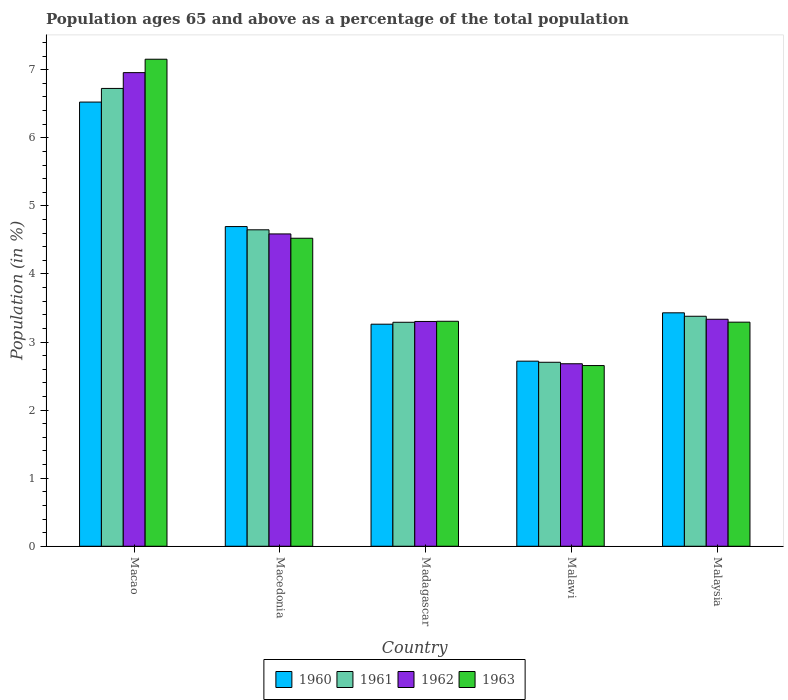How many different coloured bars are there?
Your answer should be very brief. 4. How many groups of bars are there?
Offer a terse response. 5. Are the number of bars per tick equal to the number of legend labels?
Your answer should be very brief. Yes. Are the number of bars on each tick of the X-axis equal?
Your response must be concise. Yes. How many bars are there on the 2nd tick from the left?
Your answer should be compact. 4. How many bars are there on the 3rd tick from the right?
Provide a short and direct response. 4. What is the label of the 3rd group of bars from the left?
Give a very brief answer. Madagascar. What is the percentage of the population ages 65 and above in 1963 in Macedonia?
Your answer should be very brief. 4.52. Across all countries, what is the maximum percentage of the population ages 65 and above in 1961?
Give a very brief answer. 6.73. Across all countries, what is the minimum percentage of the population ages 65 and above in 1961?
Your answer should be very brief. 2.7. In which country was the percentage of the population ages 65 and above in 1963 maximum?
Make the answer very short. Macao. In which country was the percentage of the population ages 65 and above in 1961 minimum?
Give a very brief answer. Malawi. What is the total percentage of the population ages 65 and above in 1963 in the graph?
Give a very brief answer. 20.93. What is the difference between the percentage of the population ages 65 and above in 1963 in Macedonia and that in Madagascar?
Offer a terse response. 1.22. What is the difference between the percentage of the population ages 65 and above in 1961 in Madagascar and the percentage of the population ages 65 and above in 1960 in Malawi?
Offer a very short reply. 0.57. What is the average percentage of the population ages 65 and above in 1961 per country?
Provide a succinct answer. 4.15. What is the difference between the percentage of the population ages 65 and above of/in 1963 and percentage of the population ages 65 and above of/in 1960 in Malawi?
Offer a terse response. -0.06. In how many countries, is the percentage of the population ages 65 and above in 1962 greater than 3.6?
Offer a terse response. 2. What is the ratio of the percentage of the population ages 65 and above in 1962 in Malawi to that in Malaysia?
Your response must be concise. 0.8. What is the difference between the highest and the second highest percentage of the population ages 65 and above in 1962?
Make the answer very short. -1.25. What is the difference between the highest and the lowest percentage of the population ages 65 and above in 1962?
Your answer should be compact. 4.28. In how many countries, is the percentage of the population ages 65 and above in 1962 greater than the average percentage of the population ages 65 and above in 1962 taken over all countries?
Keep it short and to the point. 2. What does the 2nd bar from the left in Malawi represents?
Give a very brief answer. 1961. Is it the case that in every country, the sum of the percentage of the population ages 65 and above in 1960 and percentage of the population ages 65 and above in 1963 is greater than the percentage of the population ages 65 and above in 1962?
Your answer should be compact. Yes. What is the difference between two consecutive major ticks on the Y-axis?
Your answer should be very brief. 1. Are the values on the major ticks of Y-axis written in scientific E-notation?
Your answer should be compact. No. Where does the legend appear in the graph?
Provide a succinct answer. Bottom center. How many legend labels are there?
Provide a succinct answer. 4. How are the legend labels stacked?
Provide a short and direct response. Horizontal. What is the title of the graph?
Keep it short and to the point. Population ages 65 and above as a percentage of the total population. What is the label or title of the X-axis?
Ensure brevity in your answer.  Country. What is the label or title of the Y-axis?
Provide a short and direct response. Population (in %). What is the Population (in %) in 1960 in Macao?
Offer a terse response. 6.53. What is the Population (in %) in 1961 in Macao?
Keep it short and to the point. 6.73. What is the Population (in %) in 1962 in Macao?
Your response must be concise. 6.96. What is the Population (in %) in 1963 in Macao?
Make the answer very short. 7.15. What is the Population (in %) in 1960 in Macedonia?
Provide a short and direct response. 4.7. What is the Population (in %) in 1961 in Macedonia?
Your answer should be compact. 4.65. What is the Population (in %) of 1962 in Macedonia?
Keep it short and to the point. 4.59. What is the Population (in %) in 1963 in Macedonia?
Offer a very short reply. 4.52. What is the Population (in %) of 1960 in Madagascar?
Make the answer very short. 3.26. What is the Population (in %) in 1961 in Madagascar?
Your response must be concise. 3.29. What is the Population (in %) of 1962 in Madagascar?
Offer a terse response. 3.3. What is the Population (in %) in 1963 in Madagascar?
Make the answer very short. 3.31. What is the Population (in %) of 1960 in Malawi?
Keep it short and to the point. 2.72. What is the Population (in %) in 1961 in Malawi?
Keep it short and to the point. 2.7. What is the Population (in %) of 1962 in Malawi?
Keep it short and to the point. 2.68. What is the Population (in %) of 1963 in Malawi?
Make the answer very short. 2.65. What is the Population (in %) of 1960 in Malaysia?
Offer a terse response. 3.43. What is the Population (in %) in 1961 in Malaysia?
Your answer should be compact. 3.38. What is the Population (in %) in 1962 in Malaysia?
Make the answer very short. 3.33. What is the Population (in %) in 1963 in Malaysia?
Keep it short and to the point. 3.29. Across all countries, what is the maximum Population (in %) in 1960?
Provide a succinct answer. 6.53. Across all countries, what is the maximum Population (in %) of 1961?
Make the answer very short. 6.73. Across all countries, what is the maximum Population (in %) of 1962?
Your answer should be compact. 6.96. Across all countries, what is the maximum Population (in %) of 1963?
Offer a terse response. 7.15. Across all countries, what is the minimum Population (in %) of 1960?
Your answer should be compact. 2.72. Across all countries, what is the minimum Population (in %) in 1961?
Give a very brief answer. 2.7. Across all countries, what is the minimum Population (in %) of 1962?
Offer a very short reply. 2.68. Across all countries, what is the minimum Population (in %) in 1963?
Provide a succinct answer. 2.65. What is the total Population (in %) of 1960 in the graph?
Your response must be concise. 20.63. What is the total Population (in %) of 1961 in the graph?
Ensure brevity in your answer.  20.75. What is the total Population (in %) in 1962 in the graph?
Your answer should be compact. 20.86. What is the total Population (in %) in 1963 in the graph?
Offer a very short reply. 20.93. What is the difference between the Population (in %) in 1960 in Macao and that in Macedonia?
Keep it short and to the point. 1.83. What is the difference between the Population (in %) of 1961 in Macao and that in Macedonia?
Offer a terse response. 2.08. What is the difference between the Population (in %) in 1962 in Macao and that in Macedonia?
Your answer should be very brief. 2.37. What is the difference between the Population (in %) in 1963 in Macao and that in Macedonia?
Offer a terse response. 2.63. What is the difference between the Population (in %) in 1960 in Macao and that in Madagascar?
Provide a succinct answer. 3.26. What is the difference between the Population (in %) of 1961 in Macao and that in Madagascar?
Provide a succinct answer. 3.44. What is the difference between the Population (in %) of 1962 in Macao and that in Madagascar?
Your response must be concise. 3.66. What is the difference between the Population (in %) of 1963 in Macao and that in Madagascar?
Ensure brevity in your answer.  3.85. What is the difference between the Population (in %) in 1960 in Macao and that in Malawi?
Your answer should be very brief. 3.81. What is the difference between the Population (in %) in 1961 in Macao and that in Malawi?
Ensure brevity in your answer.  4.02. What is the difference between the Population (in %) of 1962 in Macao and that in Malawi?
Your response must be concise. 4.28. What is the difference between the Population (in %) in 1963 in Macao and that in Malawi?
Your response must be concise. 4.5. What is the difference between the Population (in %) of 1960 in Macao and that in Malaysia?
Give a very brief answer. 3.1. What is the difference between the Population (in %) of 1961 in Macao and that in Malaysia?
Keep it short and to the point. 3.35. What is the difference between the Population (in %) of 1962 in Macao and that in Malaysia?
Give a very brief answer. 3.62. What is the difference between the Population (in %) of 1963 in Macao and that in Malaysia?
Your answer should be very brief. 3.86. What is the difference between the Population (in %) in 1960 in Macedonia and that in Madagascar?
Make the answer very short. 1.43. What is the difference between the Population (in %) of 1961 in Macedonia and that in Madagascar?
Offer a very short reply. 1.36. What is the difference between the Population (in %) in 1962 in Macedonia and that in Madagascar?
Make the answer very short. 1.29. What is the difference between the Population (in %) of 1963 in Macedonia and that in Madagascar?
Provide a succinct answer. 1.22. What is the difference between the Population (in %) in 1960 in Macedonia and that in Malawi?
Provide a succinct answer. 1.98. What is the difference between the Population (in %) of 1961 in Macedonia and that in Malawi?
Offer a terse response. 1.95. What is the difference between the Population (in %) of 1962 in Macedonia and that in Malawi?
Provide a short and direct response. 1.91. What is the difference between the Population (in %) in 1963 in Macedonia and that in Malawi?
Keep it short and to the point. 1.87. What is the difference between the Population (in %) of 1960 in Macedonia and that in Malaysia?
Provide a succinct answer. 1.27. What is the difference between the Population (in %) in 1961 in Macedonia and that in Malaysia?
Your response must be concise. 1.27. What is the difference between the Population (in %) in 1962 in Macedonia and that in Malaysia?
Keep it short and to the point. 1.25. What is the difference between the Population (in %) in 1963 in Macedonia and that in Malaysia?
Your answer should be very brief. 1.23. What is the difference between the Population (in %) of 1960 in Madagascar and that in Malawi?
Your response must be concise. 0.54. What is the difference between the Population (in %) in 1961 in Madagascar and that in Malawi?
Offer a terse response. 0.59. What is the difference between the Population (in %) in 1962 in Madagascar and that in Malawi?
Ensure brevity in your answer.  0.62. What is the difference between the Population (in %) in 1963 in Madagascar and that in Malawi?
Provide a succinct answer. 0.65. What is the difference between the Population (in %) of 1960 in Madagascar and that in Malaysia?
Keep it short and to the point. -0.17. What is the difference between the Population (in %) of 1961 in Madagascar and that in Malaysia?
Offer a very short reply. -0.09. What is the difference between the Population (in %) in 1962 in Madagascar and that in Malaysia?
Offer a terse response. -0.03. What is the difference between the Population (in %) of 1963 in Madagascar and that in Malaysia?
Your answer should be compact. 0.01. What is the difference between the Population (in %) of 1960 in Malawi and that in Malaysia?
Give a very brief answer. -0.71. What is the difference between the Population (in %) in 1961 in Malawi and that in Malaysia?
Keep it short and to the point. -0.68. What is the difference between the Population (in %) of 1962 in Malawi and that in Malaysia?
Offer a very short reply. -0.65. What is the difference between the Population (in %) in 1963 in Malawi and that in Malaysia?
Ensure brevity in your answer.  -0.64. What is the difference between the Population (in %) of 1960 in Macao and the Population (in %) of 1961 in Macedonia?
Provide a short and direct response. 1.88. What is the difference between the Population (in %) of 1960 in Macao and the Population (in %) of 1962 in Macedonia?
Offer a very short reply. 1.94. What is the difference between the Population (in %) of 1960 in Macao and the Population (in %) of 1963 in Macedonia?
Your answer should be very brief. 2. What is the difference between the Population (in %) of 1961 in Macao and the Population (in %) of 1962 in Macedonia?
Ensure brevity in your answer.  2.14. What is the difference between the Population (in %) in 1961 in Macao and the Population (in %) in 1963 in Macedonia?
Your response must be concise. 2.2. What is the difference between the Population (in %) in 1962 in Macao and the Population (in %) in 1963 in Macedonia?
Provide a short and direct response. 2.43. What is the difference between the Population (in %) of 1960 in Macao and the Population (in %) of 1961 in Madagascar?
Keep it short and to the point. 3.23. What is the difference between the Population (in %) of 1960 in Macao and the Population (in %) of 1962 in Madagascar?
Keep it short and to the point. 3.22. What is the difference between the Population (in %) in 1960 in Macao and the Population (in %) in 1963 in Madagascar?
Your answer should be very brief. 3.22. What is the difference between the Population (in %) of 1961 in Macao and the Population (in %) of 1962 in Madagascar?
Give a very brief answer. 3.42. What is the difference between the Population (in %) in 1961 in Macao and the Population (in %) in 1963 in Madagascar?
Give a very brief answer. 3.42. What is the difference between the Population (in %) of 1962 in Macao and the Population (in %) of 1963 in Madagascar?
Ensure brevity in your answer.  3.65. What is the difference between the Population (in %) of 1960 in Macao and the Population (in %) of 1961 in Malawi?
Provide a short and direct response. 3.82. What is the difference between the Population (in %) of 1960 in Macao and the Population (in %) of 1962 in Malawi?
Give a very brief answer. 3.84. What is the difference between the Population (in %) of 1960 in Macao and the Population (in %) of 1963 in Malawi?
Make the answer very short. 3.87. What is the difference between the Population (in %) of 1961 in Macao and the Population (in %) of 1962 in Malawi?
Ensure brevity in your answer.  4.04. What is the difference between the Population (in %) of 1961 in Macao and the Population (in %) of 1963 in Malawi?
Give a very brief answer. 4.07. What is the difference between the Population (in %) of 1962 in Macao and the Population (in %) of 1963 in Malawi?
Ensure brevity in your answer.  4.3. What is the difference between the Population (in %) in 1960 in Macao and the Population (in %) in 1961 in Malaysia?
Provide a short and direct response. 3.15. What is the difference between the Population (in %) in 1960 in Macao and the Population (in %) in 1962 in Malaysia?
Provide a succinct answer. 3.19. What is the difference between the Population (in %) in 1960 in Macao and the Population (in %) in 1963 in Malaysia?
Offer a terse response. 3.23. What is the difference between the Population (in %) in 1961 in Macao and the Population (in %) in 1962 in Malaysia?
Your response must be concise. 3.39. What is the difference between the Population (in %) in 1961 in Macao and the Population (in %) in 1963 in Malaysia?
Offer a very short reply. 3.43. What is the difference between the Population (in %) in 1962 in Macao and the Population (in %) in 1963 in Malaysia?
Your answer should be compact. 3.67. What is the difference between the Population (in %) in 1960 in Macedonia and the Population (in %) in 1961 in Madagascar?
Your answer should be compact. 1.41. What is the difference between the Population (in %) in 1960 in Macedonia and the Population (in %) in 1962 in Madagascar?
Provide a short and direct response. 1.39. What is the difference between the Population (in %) of 1960 in Macedonia and the Population (in %) of 1963 in Madagascar?
Provide a short and direct response. 1.39. What is the difference between the Population (in %) of 1961 in Macedonia and the Population (in %) of 1962 in Madagascar?
Your answer should be compact. 1.35. What is the difference between the Population (in %) of 1961 in Macedonia and the Population (in %) of 1963 in Madagascar?
Give a very brief answer. 1.34. What is the difference between the Population (in %) of 1962 in Macedonia and the Population (in %) of 1963 in Madagascar?
Offer a terse response. 1.28. What is the difference between the Population (in %) in 1960 in Macedonia and the Population (in %) in 1961 in Malawi?
Offer a very short reply. 1.99. What is the difference between the Population (in %) of 1960 in Macedonia and the Population (in %) of 1962 in Malawi?
Ensure brevity in your answer.  2.02. What is the difference between the Population (in %) of 1960 in Macedonia and the Population (in %) of 1963 in Malawi?
Provide a short and direct response. 2.04. What is the difference between the Population (in %) of 1961 in Macedonia and the Population (in %) of 1962 in Malawi?
Provide a succinct answer. 1.97. What is the difference between the Population (in %) of 1961 in Macedonia and the Population (in %) of 1963 in Malawi?
Offer a very short reply. 1.99. What is the difference between the Population (in %) of 1962 in Macedonia and the Population (in %) of 1963 in Malawi?
Keep it short and to the point. 1.93. What is the difference between the Population (in %) in 1960 in Macedonia and the Population (in %) in 1961 in Malaysia?
Make the answer very short. 1.32. What is the difference between the Population (in %) in 1960 in Macedonia and the Population (in %) in 1962 in Malaysia?
Offer a terse response. 1.36. What is the difference between the Population (in %) in 1960 in Macedonia and the Population (in %) in 1963 in Malaysia?
Offer a terse response. 1.4. What is the difference between the Population (in %) in 1961 in Macedonia and the Population (in %) in 1962 in Malaysia?
Your answer should be compact. 1.31. What is the difference between the Population (in %) in 1961 in Macedonia and the Population (in %) in 1963 in Malaysia?
Your response must be concise. 1.36. What is the difference between the Population (in %) of 1962 in Macedonia and the Population (in %) of 1963 in Malaysia?
Provide a short and direct response. 1.3. What is the difference between the Population (in %) of 1960 in Madagascar and the Population (in %) of 1961 in Malawi?
Ensure brevity in your answer.  0.56. What is the difference between the Population (in %) of 1960 in Madagascar and the Population (in %) of 1962 in Malawi?
Provide a succinct answer. 0.58. What is the difference between the Population (in %) in 1960 in Madagascar and the Population (in %) in 1963 in Malawi?
Offer a very short reply. 0.61. What is the difference between the Population (in %) in 1961 in Madagascar and the Population (in %) in 1962 in Malawi?
Make the answer very short. 0.61. What is the difference between the Population (in %) of 1961 in Madagascar and the Population (in %) of 1963 in Malawi?
Give a very brief answer. 0.64. What is the difference between the Population (in %) of 1962 in Madagascar and the Population (in %) of 1963 in Malawi?
Give a very brief answer. 0.65. What is the difference between the Population (in %) in 1960 in Madagascar and the Population (in %) in 1961 in Malaysia?
Give a very brief answer. -0.12. What is the difference between the Population (in %) in 1960 in Madagascar and the Population (in %) in 1962 in Malaysia?
Ensure brevity in your answer.  -0.07. What is the difference between the Population (in %) of 1960 in Madagascar and the Population (in %) of 1963 in Malaysia?
Offer a terse response. -0.03. What is the difference between the Population (in %) in 1961 in Madagascar and the Population (in %) in 1962 in Malaysia?
Your answer should be compact. -0.04. What is the difference between the Population (in %) of 1961 in Madagascar and the Population (in %) of 1963 in Malaysia?
Your answer should be compact. -0. What is the difference between the Population (in %) in 1962 in Madagascar and the Population (in %) in 1963 in Malaysia?
Your answer should be compact. 0.01. What is the difference between the Population (in %) of 1960 in Malawi and the Population (in %) of 1961 in Malaysia?
Your response must be concise. -0.66. What is the difference between the Population (in %) in 1960 in Malawi and the Population (in %) in 1962 in Malaysia?
Provide a succinct answer. -0.62. What is the difference between the Population (in %) in 1960 in Malawi and the Population (in %) in 1963 in Malaysia?
Your response must be concise. -0.57. What is the difference between the Population (in %) of 1961 in Malawi and the Population (in %) of 1962 in Malaysia?
Offer a very short reply. -0.63. What is the difference between the Population (in %) of 1961 in Malawi and the Population (in %) of 1963 in Malaysia?
Offer a very short reply. -0.59. What is the difference between the Population (in %) of 1962 in Malawi and the Population (in %) of 1963 in Malaysia?
Make the answer very short. -0.61. What is the average Population (in %) in 1960 per country?
Give a very brief answer. 4.13. What is the average Population (in %) of 1961 per country?
Your answer should be compact. 4.15. What is the average Population (in %) of 1962 per country?
Make the answer very short. 4.17. What is the average Population (in %) of 1963 per country?
Make the answer very short. 4.19. What is the difference between the Population (in %) in 1960 and Population (in %) in 1961 in Macao?
Your response must be concise. -0.2. What is the difference between the Population (in %) of 1960 and Population (in %) of 1962 in Macao?
Keep it short and to the point. -0.43. What is the difference between the Population (in %) in 1960 and Population (in %) in 1963 in Macao?
Your answer should be very brief. -0.63. What is the difference between the Population (in %) in 1961 and Population (in %) in 1962 in Macao?
Keep it short and to the point. -0.23. What is the difference between the Population (in %) in 1961 and Population (in %) in 1963 in Macao?
Offer a very short reply. -0.43. What is the difference between the Population (in %) of 1962 and Population (in %) of 1963 in Macao?
Your answer should be very brief. -0.2. What is the difference between the Population (in %) of 1960 and Population (in %) of 1961 in Macedonia?
Make the answer very short. 0.05. What is the difference between the Population (in %) of 1960 and Population (in %) of 1962 in Macedonia?
Offer a terse response. 0.11. What is the difference between the Population (in %) in 1960 and Population (in %) in 1963 in Macedonia?
Offer a very short reply. 0.17. What is the difference between the Population (in %) in 1961 and Population (in %) in 1962 in Macedonia?
Offer a very short reply. 0.06. What is the difference between the Population (in %) of 1961 and Population (in %) of 1963 in Macedonia?
Provide a succinct answer. 0.12. What is the difference between the Population (in %) in 1962 and Population (in %) in 1963 in Macedonia?
Your answer should be very brief. 0.06. What is the difference between the Population (in %) of 1960 and Population (in %) of 1961 in Madagascar?
Ensure brevity in your answer.  -0.03. What is the difference between the Population (in %) of 1960 and Population (in %) of 1962 in Madagascar?
Give a very brief answer. -0.04. What is the difference between the Population (in %) in 1960 and Population (in %) in 1963 in Madagascar?
Give a very brief answer. -0.04. What is the difference between the Population (in %) in 1961 and Population (in %) in 1962 in Madagascar?
Provide a short and direct response. -0.01. What is the difference between the Population (in %) of 1961 and Population (in %) of 1963 in Madagascar?
Keep it short and to the point. -0.01. What is the difference between the Population (in %) in 1962 and Population (in %) in 1963 in Madagascar?
Provide a short and direct response. -0. What is the difference between the Population (in %) of 1960 and Population (in %) of 1961 in Malawi?
Ensure brevity in your answer.  0.02. What is the difference between the Population (in %) of 1960 and Population (in %) of 1962 in Malawi?
Your response must be concise. 0.04. What is the difference between the Population (in %) in 1960 and Population (in %) in 1963 in Malawi?
Ensure brevity in your answer.  0.06. What is the difference between the Population (in %) of 1961 and Population (in %) of 1962 in Malawi?
Offer a very short reply. 0.02. What is the difference between the Population (in %) in 1961 and Population (in %) in 1963 in Malawi?
Provide a succinct answer. 0.05. What is the difference between the Population (in %) of 1962 and Population (in %) of 1963 in Malawi?
Keep it short and to the point. 0.03. What is the difference between the Population (in %) of 1960 and Population (in %) of 1961 in Malaysia?
Make the answer very short. 0.05. What is the difference between the Population (in %) of 1960 and Population (in %) of 1962 in Malaysia?
Your answer should be compact. 0.09. What is the difference between the Population (in %) of 1960 and Population (in %) of 1963 in Malaysia?
Your response must be concise. 0.14. What is the difference between the Population (in %) in 1961 and Population (in %) in 1962 in Malaysia?
Provide a short and direct response. 0.04. What is the difference between the Population (in %) of 1961 and Population (in %) of 1963 in Malaysia?
Offer a terse response. 0.09. What is the difference between the Population (in %) of 1962 and Population (in %) of 1963 in Malaysia?
Your response must be concise. 0.04. What is the ratio of the Population (in %) of 1960 in Macao to that in Macedonia?
Offer a very short reply. 1.39. What is the ratio of the Population (in %) of 1961 in Macao to that in Macedonia?
Your answer should be compact. 1.45. What is the ratio of the Population (in %) in 1962 in Macao to that in Macedonia?
Give a very brief answer. 1.52. What is the ratio of the Population (in %) of 1963 in Macao to that in Macedonia?
Your answer should be compact. 1.58. What is the ratio of the Population (in %) in 1960 in Macao to that in Madagascar?
Provide a succinct answer. 2. What is the ratio of the Population (in %) of 1961 in Macao to that in Madagascar?
Give a very brief answer. 2.04. What is the ratio of the Population (in %) in 1962 in Macao to that in Madagascar?
Provide a succinct answer. 2.11. What is the ratio of the Population (in %) of 1963 in Macao to that in Madagascar?
Provide a succinct answer. 2.16. What is the ratio of the Population (in %) in 1960 in Macao to that in Malawi?
Your response must be concise. 2.4. What is the ratio of the Population (in %) of 1961 in Macao to that in Malawi?
Ensure brevity in your answer.  2.49. What is the ratio of the Population (in %) in 1962 in Macao to that in Malawi?
Offer a very short reply. 2.6. What is the ratio of the Population (in %) in 1963 in Macao to that in Malawi?
Give a very brief answer. 2.7. What is the ratio of the Population (in %) of 1960 in Macao to that in Malaysia?
Keep it short and to the point. 1.9. What is the ratio of the Population (in %) in 1961 in Macao to that in Malaysia?
Make the answer very short. 1.99. What is the ratio of the Population (in %) of 1962 in Macao to that in Malaysia?
Provide a succinct answer. 2.09. What is the ratio of the Population (in %) in 1963 in Macao to that in Malaysia?
Your answer should be very brief. 2.17. What is the ratio of the Population (in %) in 1960 in Macedonia to that in Madagascar?
Your answer should be very brief. 1.44. What is the ratio of the Population (in %) of 1961 in Macedonia to that in Madagascar?
Offer a very short reply. 1.41. What is the ratio of the Population (in %) of 1962 in Macedonia to that in Madagascar?
Your response must be concise. 1.39. What is the ratio of the Population (in %) in 1963 in Macedonia to that in Madagascar?
Provide a succinct answer. 1.37. What is the ratio of the Population (in %) of 1960 in Macedonia to that in Malawi?
Ensure brevity in your answer.  1.73. What is the ratio of the Population (in %) of 1961 in Macedonia to that in Malawi?
Provide a succinct answer. 1.72. What is the ratio of the Population (in %) in 1962 in Macedonia to that in Malawi?
Your response must be concise. 1.71. What is the ratio of the Population (in %) in 1963 in Macedonia to that in Malawi?
Ensure brevity in your answer.  1.7. What is the ratio of the Population (in %) of 1960 in Macedonia to that in Malaysia?
Offer a very short reply. 1.37. What is the ratio of the Population (in %) of 1961 in Macedonia to that in Malaysia?
Your answer should be compact. 1.38. What is the ratio of the Population (in %) in 1962 in Macedonia to that in Malaysia?
Ensure brevity in your answer.  1.38. What is the ratio of the Population (in %) in 1963 in Macedonia to that in Malaysia?
Ensure brevity in your answer.  1.37. What is the ratio of the Population (in %) in 1960 in Madagascar to that in Malawi?
Provide a succinct answer. 1.2. What is the ratio of the Population (in %) of 1961 in Madagascar to that in Malawi?
Ensure brevity in your answer.  1.22. What is the ratio of the Population (in %) of 1962 in Madagascar to that in Malawi?
Offer a very short reply. 1.23. What is the ratio of the Population (in %) of 1963 in Madagascar to that in Malawi?
Your answer should be very brief. 1.25. What is the ratio of the Population (in %) of 1960 in Madagascar to that in Malaysia?
Your response must be concise. 0.95. What is the ratio of the Population (in %) of 1961 in Madagascar to that in Malaysia?
Provide a short and direct response. 0.97. What is the ratio of the Population (in %) of 1962 in Madagascar to that in Malaysia?
Provide a succinct answer. 0.99. What is the ratio of the Population (in %) of 1963 in Madagascar to that in Malaysia?
Ensure brevity in your answer.  1. What is the ratio of the Population (in %) in 1960 in Malawi to that in Malaysia?
Provide a succinct answer. 0.79. What is the ratio of the Population (in %) in 1962 in Malawi to that in Malaysia?
Provide a short and direct response. 0.8. What is the ratio of the Population (in %) in 1963 in Malawi to that in Malaysia?
Your response must be concise. 0.81. What is the difference between the highest and the second highest Population (in %) of 1960?
Offer a very short reply. 1.83. What is the difference between the highest and the second highest Population (in %) of 1961?
Keep it short and to the point. 2.08. What is the difference between the highest and the second highest Population (in %) of 1962?
Offer a terse response. 2.37. What is the difference between the highest and the second highest Population (in %) of 1963?
Give a very brief answer. 2.63. What is the difference between the highest and the lowest Population (in %) of 1960?
Offer a terse response. 3.81. What is the difference between the highest and the lowest Population (in %) of 1961?
Ensure brevity in your answer.  4.02. What is the difference between the highest and the lowest Population (in %) in 1962?
Give a very brief answer. 4.28. What is the difference between the highest and the lowest Population (in %) in 1963?
Provide a short and direct response. 4.5. 